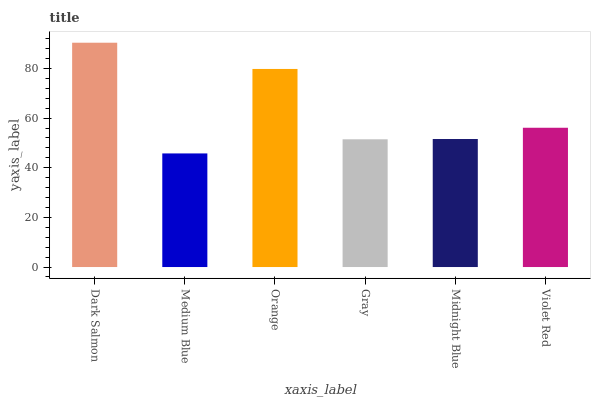Is Medium Blue the minimum?
Answer yes or no. Yes. Is Dark Salmon the maximum?
Answer yes or no. Yes. Is Orange the minimum?
Answer yes or no. No. Is Orange the maximum?
Answer yes or no. No. Is Orange greater than Medium Blue?
Answer yes or no. Yes. Is Medium Blue less than Orange?
Answer yes or no. Yes. Is Medium Blue greater than Orange?
Answer yes or no. No. Is Orange less than Medium Blue?
Answer yes or no. No. Is Violet Red the high median?
Answer yes or no. Yes. Is Midnight Blue the low median?
Answer yes or no. Yes. Is Gray the high median?
Answer yes or no. No. Is Violet Red the low median?
Answer yes or no. No. 